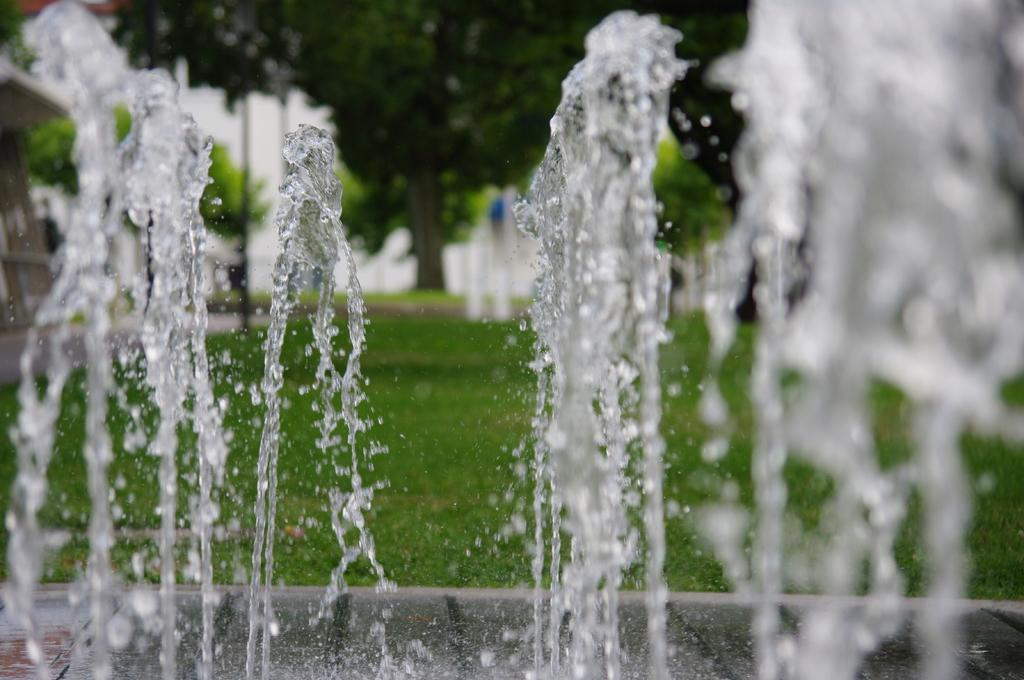What is the main feature in the image? There is a fountain in the image. Where is the water located in the image? The water is on the right side of the image. What can be seen in the background of the image? There is a building, trees, plants, and grass in the background of the image. Can you see a glove being used to fly a plane in the image? There is no glove or plane present in the image. Is there a horse-drawn carriage visible in the image? There is no horse-drawn carriage present in the image. 